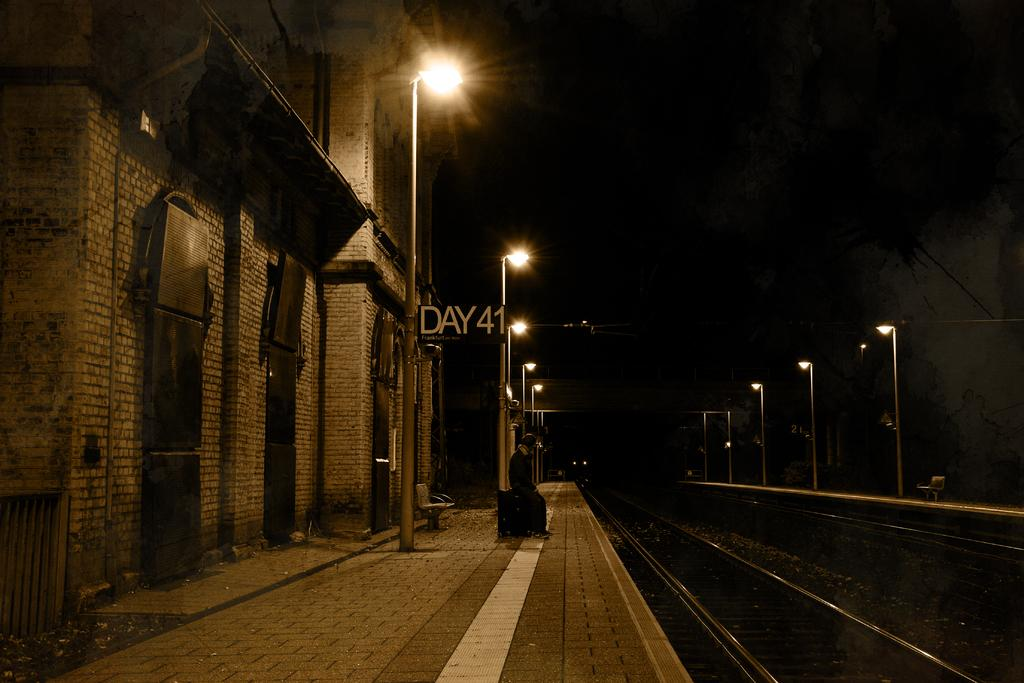<image>
Give a short and clear explanation of the subsequent image. A horizontal sign on the side of the building reads day 41. 